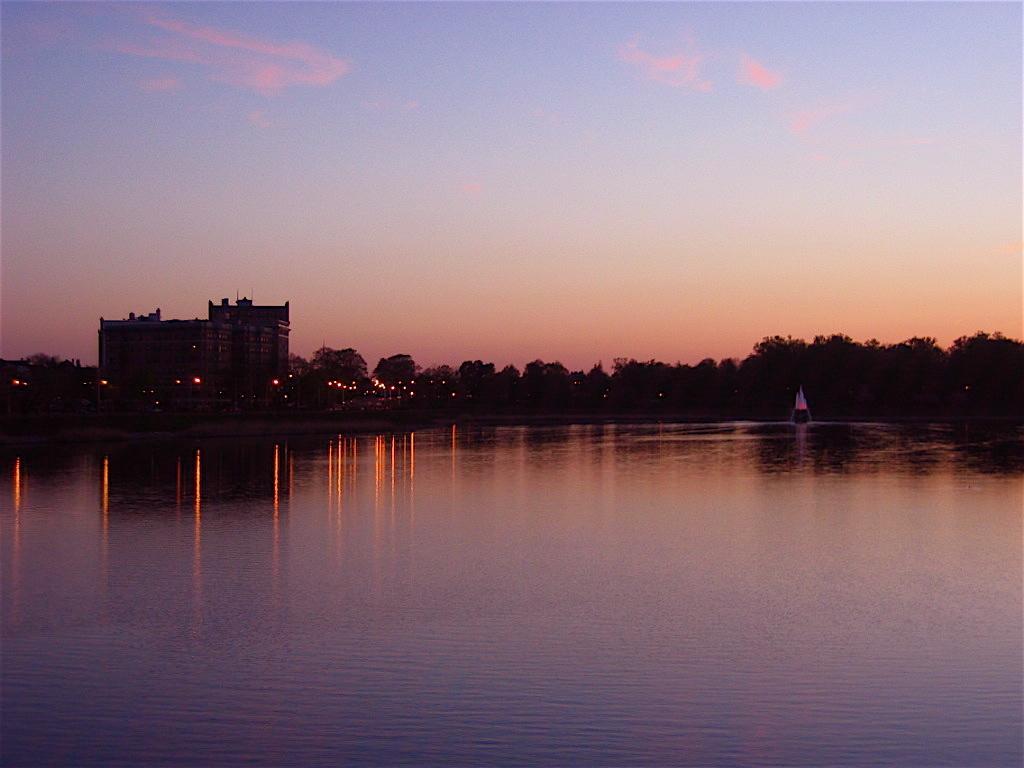How would you summarize this image in a sentence or two? This image is taken outdoors. At the top of the image there is the sky with clouds. At the bottom of the image there is a river with water. In the background there are many trees and plants and there are a few buildings and there are a few lights. 